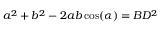<formula> <loc_0><loc_0><loc_500><loc_500>a ^ { 2 } + b ^ { 2 } - 2 a b \cos ( \alpha ) = B D ^ { 2 }</formula> 